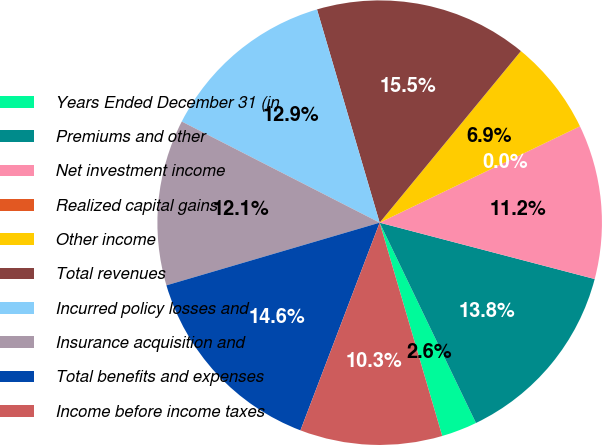<chart> <loc_0><loc_0><loc_500><loc_500><pie_chart><fcel>Years Ended December 31 (in<fcel>Premiums and other<fcel>Net investment income<fcel>Realized capital gains<fcel>Other income<fcel>Total revenues<fcel>Incurred policy losses and<fcel>Insurance acquisition and<fcel>Total benefits and expenses<fcel>Income before income taxes<nl><fcel>2.59%<fcel>13.79%<fcel>11.21%<fcel>0.01%<fcel>6.9%<fcel>15.51%<fcel>12.93%<fcel>12.07%<fcel>14.65%<fcel>10.34%<nl></chart> 